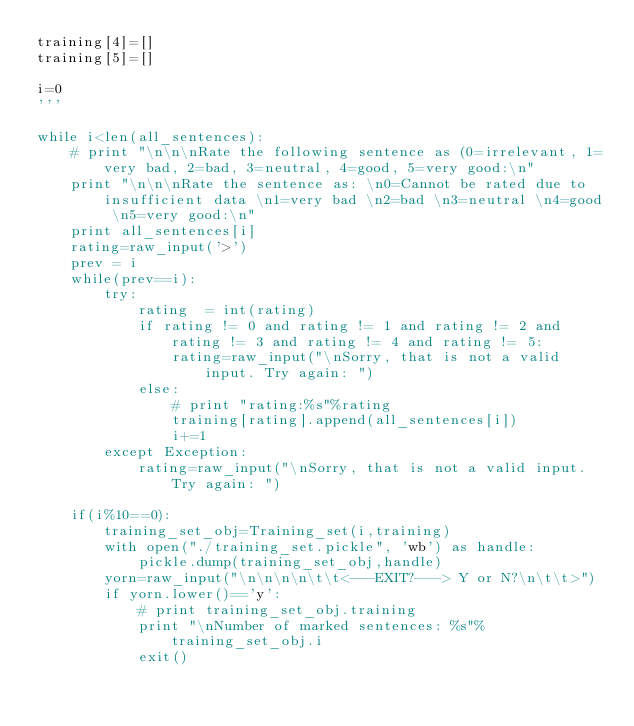Convert code to text. <code><loc_0><loc_0><loc_500><loc_500><_Cython_>training[4]=[]
training[5]=[]

i=0
'''

while i<len(all_sentences):
	# print "\n\n\nRate the following sentence as (0=irrelevant, 1=very bad, 2=bad, 3=neutral, 4=good, 5=very good:\n"
	print "\n\n\nRate the sentence as: \n0=Cannot be rated due to insufficient data \n1=very bad \n2=bad \n3=neutral \n4=good \n5=very good:\n"
	print all_sentences[i]
	rating=raw_input('>')
	prev = i
	while(prev==i):
		try:
			rating  = int(rating)
			if rating != 0 and rating != 1 and rating != 2 and rating != 3 and rating != 4 and rating != 5:
				rating=raw_input("\nSorry, that is not a valid input. Try again: ")
			else:
				# print "rating:%s"%rating
				training[rating].append(all_sentences[i])
				i+=1
		except Exception:
			rating=raw_input("\nSorry, that is not a valid input. Try again: ")

	if(i%10==0):
		training_set_obj=Training_set(i,training)
		with open("./training_set.pickle", 'wb') as handle:
			pickle.dump(training_set_obj,handle)
		yorn=raw_input("\n\n\n\n\t\t<---EXIT?---> Y or N?\n\t\t>")
		if yorn.lower()=='y':
			# print training_set_obj.training
			print "\nNumber of marked sentences: %s"%training_set_obj.i
			exit()
</code> 